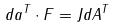Convert formula to latex. <formula><loc_0><loc_0><loc_500><loc_500>d a ^ { T } \cdot F = J d A ^ { T }</formula> 